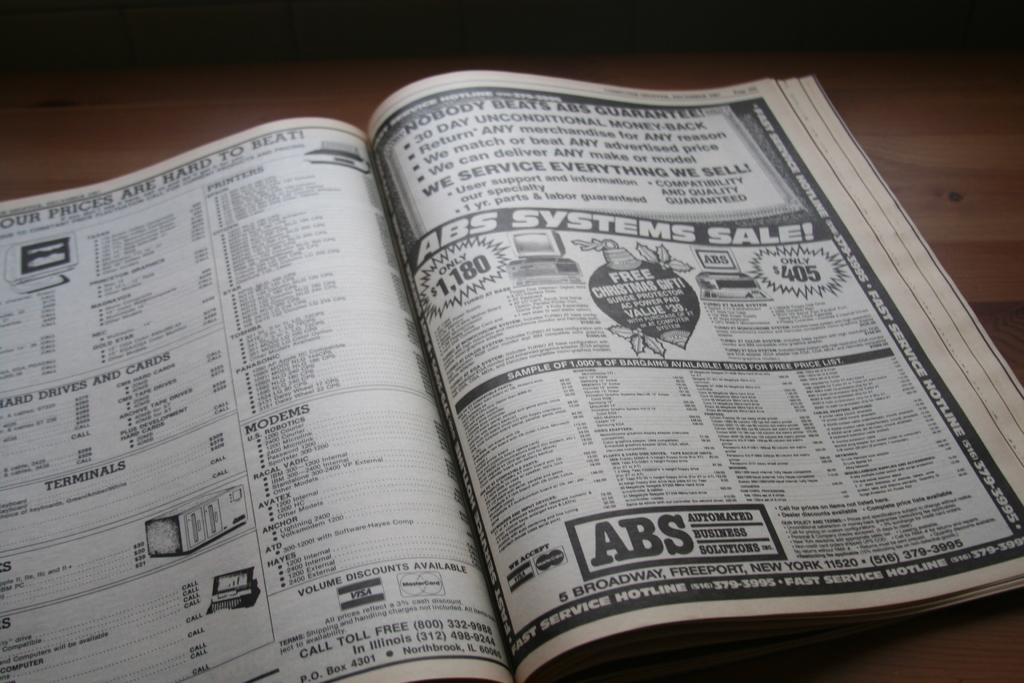<image>
Offer a succinct explanation of the picture presented. A book is open with an ad showing for ABS Automated Business Solutions on the right side. 